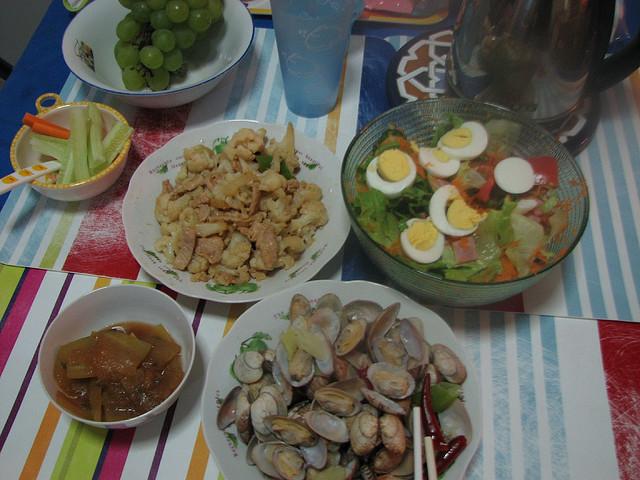Is there seafood?
Short answer required. Yes. How many plates are there?
Answer briefly. 2. What is the food sitting in?
Short answer required. Bowls. Can you see eggs in a bowl?
Answer briefly. Yes. What kind of food is next to the greens?
Quick response, please. Clams. Is this a healthy meal?
Answer briefly. Yes. What is the name of the seafood displayed?
Short answer required. Oysters. 